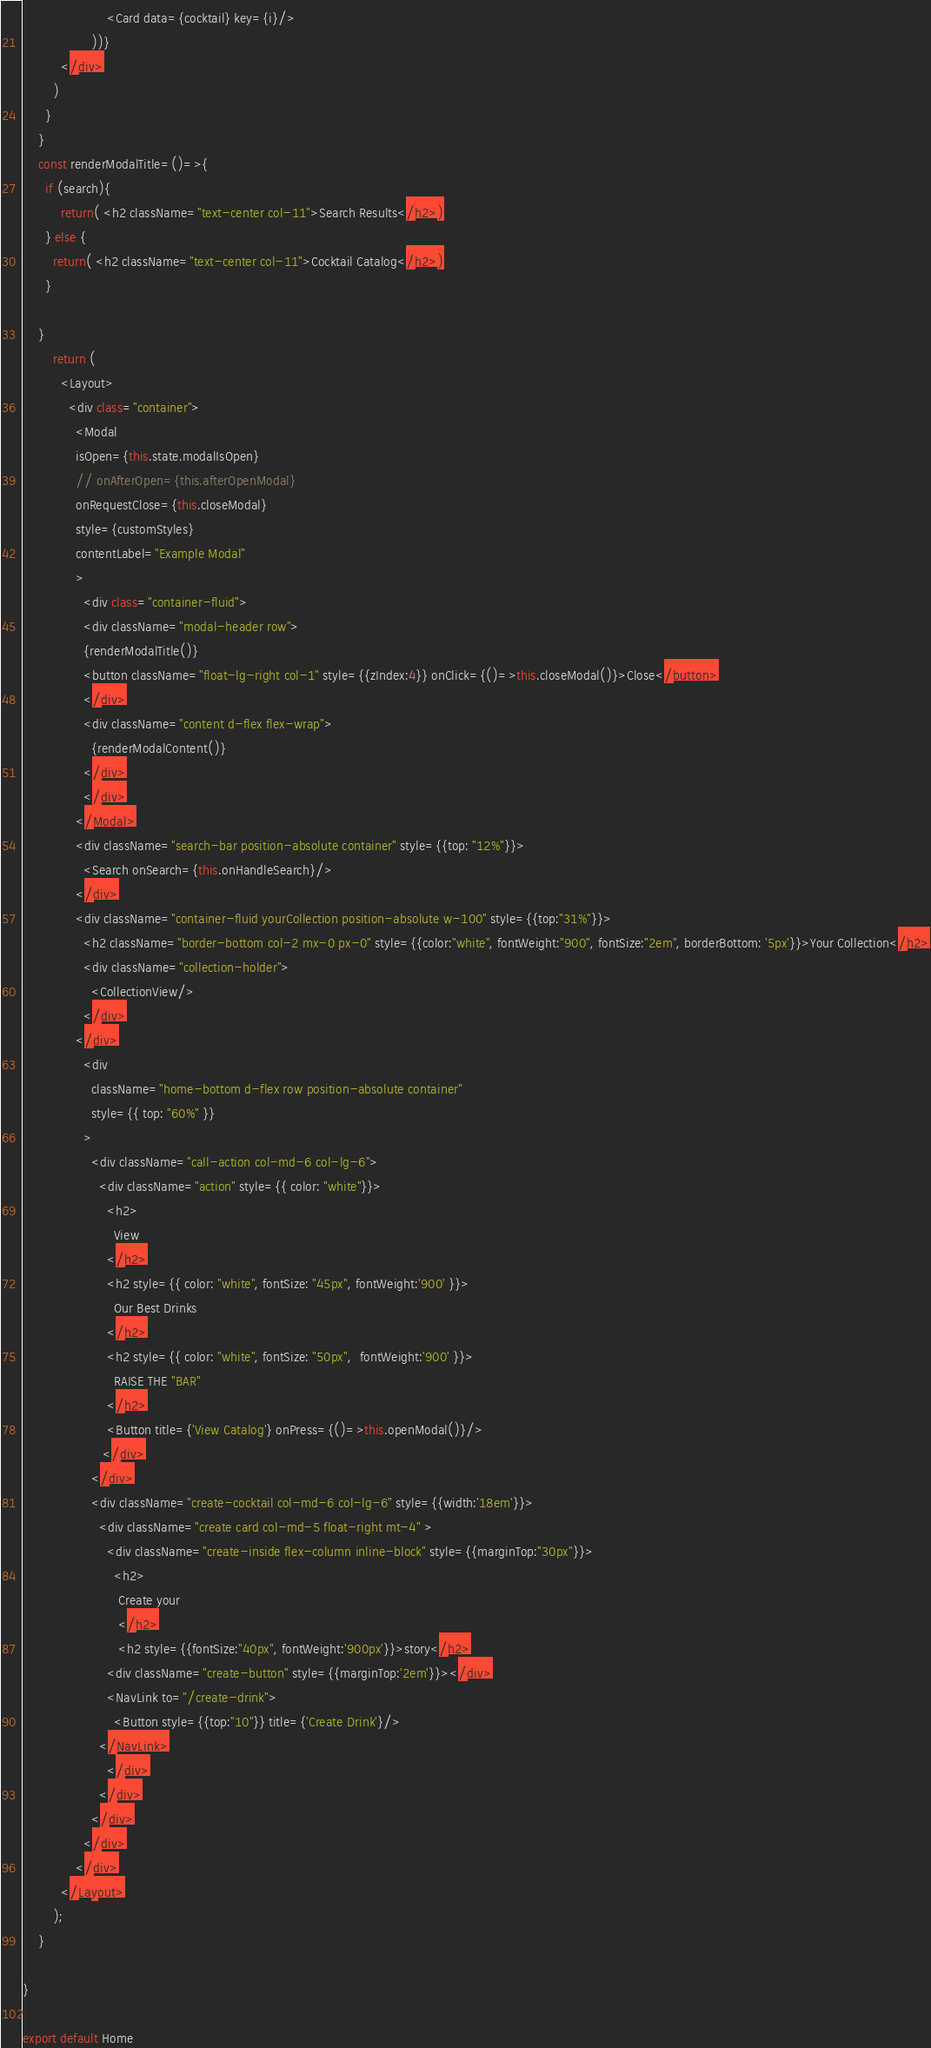<code> <loc_0><loc_0><loc_500><loc_500><_JavaScript_>                      <Card data={cocktail} key={i}/>
                  ))}
          </div>
        )
      }
    }
    const renderModalTitle=()=>{
      if (search){
          return( <h2 className="text-center col-11">Search Results</h2>)
      } else {
        return( <h2 className="text-center col-11">Cocktail Catalog</h2>)
      }

    }
        return (
          <Layout>
            <div class="container">
              <Modal 
              isOpen={this.state.modalIsOpen}
              // onAfterOpen={this.afterOpenModal}
              onRequestClose={this.closeModal}
              style={customStyles}
              contentLabel="Example Modal"
              >
                <div class="container-fluid">
                <div className="modal-header row">
                {renderModalTitle()}
                <button className="float-lg-right col-1" style={{zIndex:4}} onClick={()=>this.closeModal()}>Close</button>
                </div>
                <div className="content d-flex flex-wrap">
                  {renderModalContent()}
                </div>
                </div>
              </Modal>
              <div className="search-bar position-absolute container" style={{top: "12%"}}>
                <Search onSearch={this.onHandleSearch}/>
              </div>
              <div className="container-fluid yourCollection position-absolute w-100" style={{top:"31%"}}>
                <h2 className="border-bottom col-2 mx-0 px-0" style={{color:"white", fontWeight:"900", fontSize:"2em", borderBottom: '5px'}}>Your Collection</h2>
                <div className="collection-holder">
                  <CollectionView/>
                </div>
              </div>
                <div
                  className="home-bottom d-flex row position-absolute container"
                  style={{ top: "60%" }}
                >
                  <div className="call-action col-md-6 col-lg-6">
                    <div className="action" style={{ color: "white"}}>
                      <h2>
                        View
                      </h2>
                      <h2 style={{ color: "white", fontSize: "45px", fontWeight:'900' }}>
                        Our Best Drinks
                      </h2>
                      <h2 style={{ color: "white", fontSize: "50px",  fontWeight:'900' }}>
                        RAISE THE "BAR"
                      </h2>
                      <Button title={'View Catalog'} onPress={()=>this.openModal()}/>
                     </div>
                  </div>
                  <div className="create-cocktail col-md-6 col-lg-6" style={{width:'18em'}}>
                    <div className="create card col-md-5 float-right mt-4" >
                      <div className="create-inside flex-column inline-block" style={{marginTop:"30px"}}>
                        <h2>
                         Create your
                         </h2>
                         <h2 style={{fontSize:"40px", fontWeight:'900px'}}>story</h2>
                      <div className="create-button" style={{marginTop:'2em'}}></div>
                      <NavLink to="/create-drink">
                        <Button style={{top:"10"}} title={'Create Drink'}/>                        
                    </NavLink>
                      </div>
                    </div>
                  </div>
                </div>
              </div>
          </Layout>
        );
    }
 
}

export default Home

</code> 